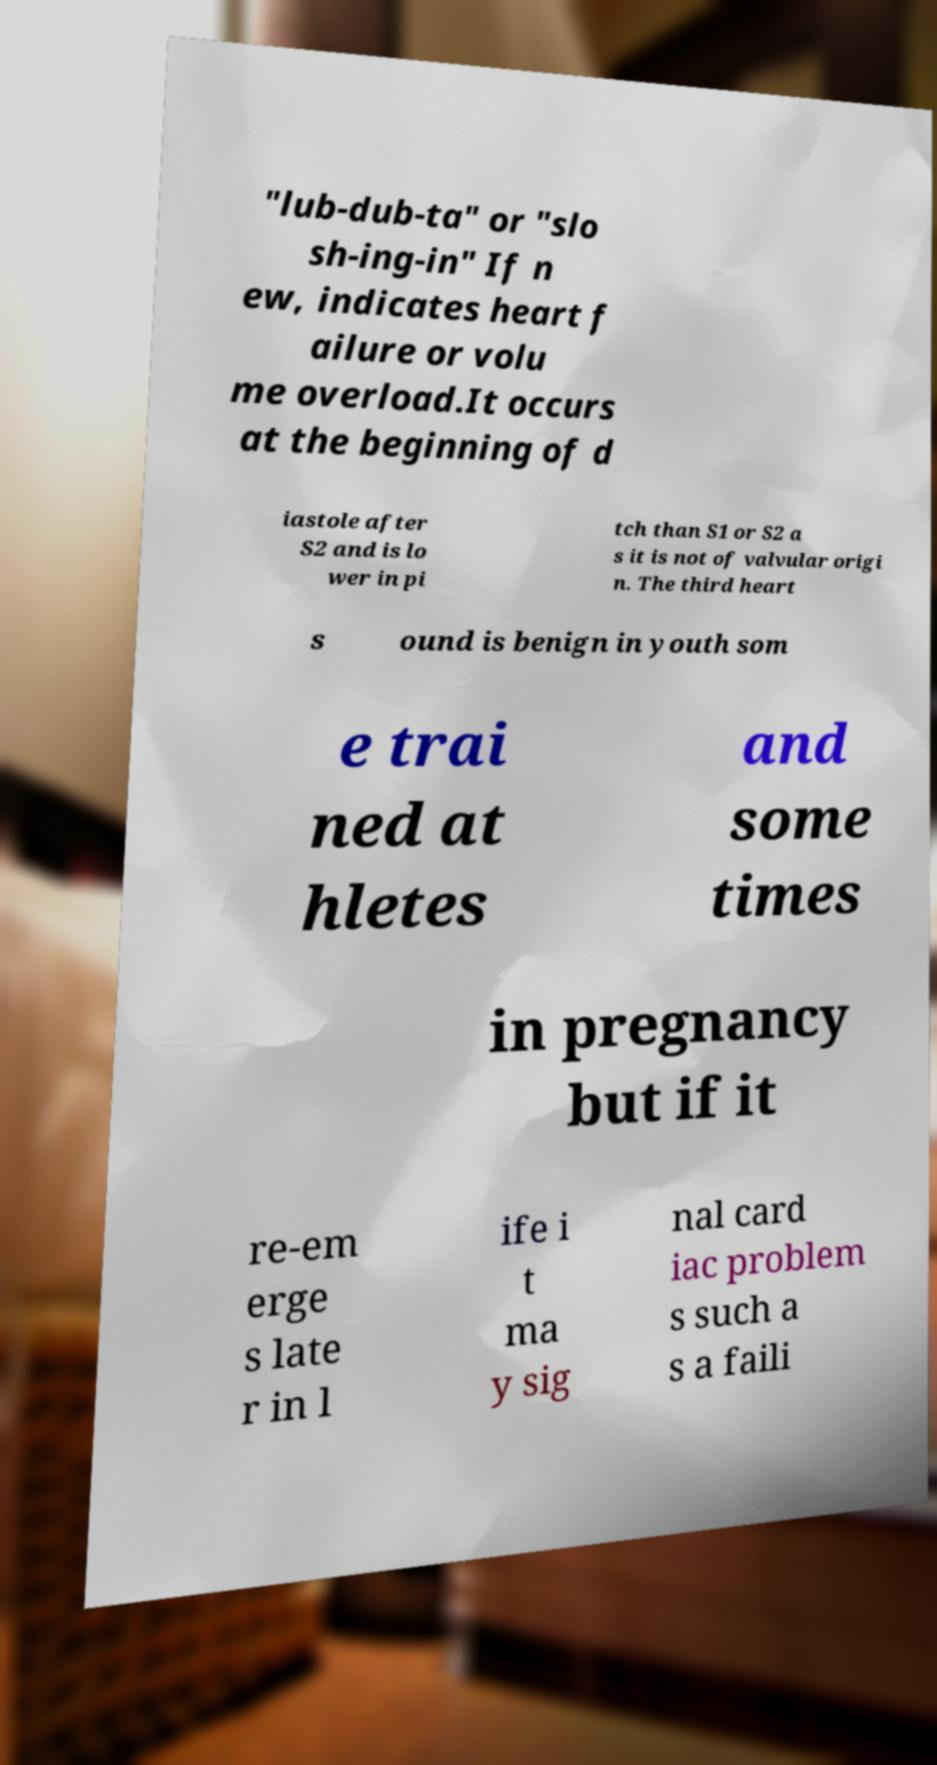Could you extract and type out the text from this image? "lub-dub-ta" or "slo sh-ing-in" If n ew, indicates heart f ailure or volu me overload.It occurs at the beginning of d iastole after S2 and is lo wer in pi tch than S1 or S2 a s it is not of valvular origi n. The third heart s ound is benign in youth som e trai ned at hletes and some times in pregnancy but if it re-em erge s late r in l ife i t ma y sig nal card iac problem s such a s a faili 